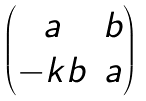Convert formula to latex. <formula><loc_0><loc_0><loc_500><loc_500>\begin{pmatrix} a & b \\ - k b & a \end{pmatrix}</formula> 